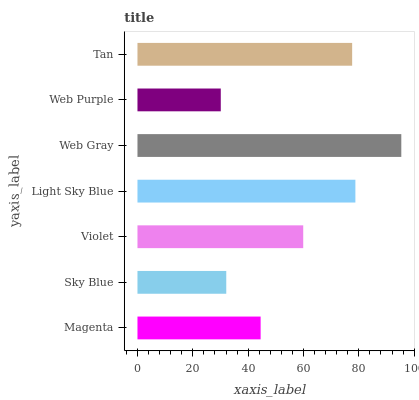Is Web Purple the minimum?
Answer yes or no. Yes. Is Web Gray the maximum?
Answer yes or no. Yes. Is Sky Blue the minimum?
Answer yes or no. No. Is Sky Blue the maximum?
Answer yes or no. No. Is Magenta greater than Sky Blue?
Answer yes or no. Yes. Is Sky Blue less than Magenta?
Answer yes or no. Yes. Is Sky Blue greater than Magenta?
Answer yes or no. No. Is Magenta less than Sky Blue?
Answer yes or no. No. Is Violet the high median?
Answer yes or no. Yes. Is Violet the low median?
Answer yes or no. Yes. Is Light Sky Blue the high median?
Answer yes or no. No. Is Web Purple the low median?
Answer yes or no. No. 